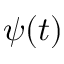<formula> <loc_0><loc_0><loc_500><loc_500>\psi ( t )</formula> 